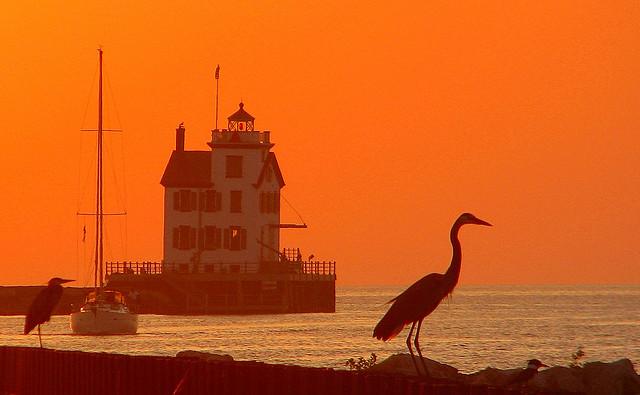What are the dark birds?
Answer briefly. Cranes. What color is the sky?
Be succinct. Orange. Are the two birds the same kind?
Concise answer only. No. Is the boat going to crash into the house?
Give a very brief answer. No. 